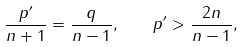Convert formula to latex. <formula><loc_0><loc_0><loc_500><loc_500>\frac { p ^ { \prime } } { n + 1 } = \frac { q } { n - 1 } , \quad p ^ { \prime } > \frac { 2 n } { n - 1 } ,</formula> 